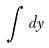Convert formula to latex. <formula><loc_0><loc_0><loc_500><loc_500>\int d y</formula> 